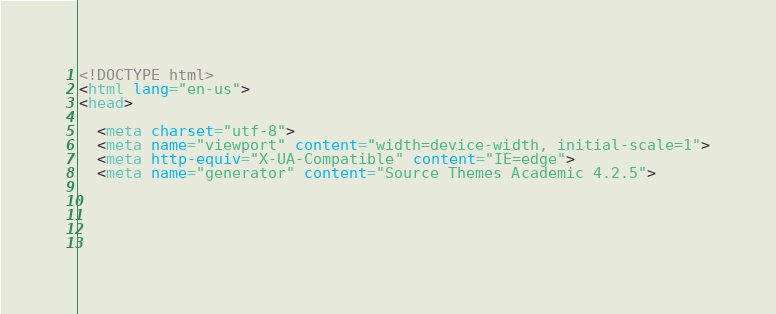Convert code to text. <code><loc_0><loc_0><loc_500><loc_500><_HTML_><!DOCTYPE html>
<html lang="en-us">
<head>

  <meta charset="utf-8">
  <meta name="viewport" content="width=device-width, initial-scale=1">
  <meta http-equiv="X-UA-Compatible" content="IE=edge">
  <meta name="generator" content="Source Themes Academic 4.2.5">

  

  
  </code> 